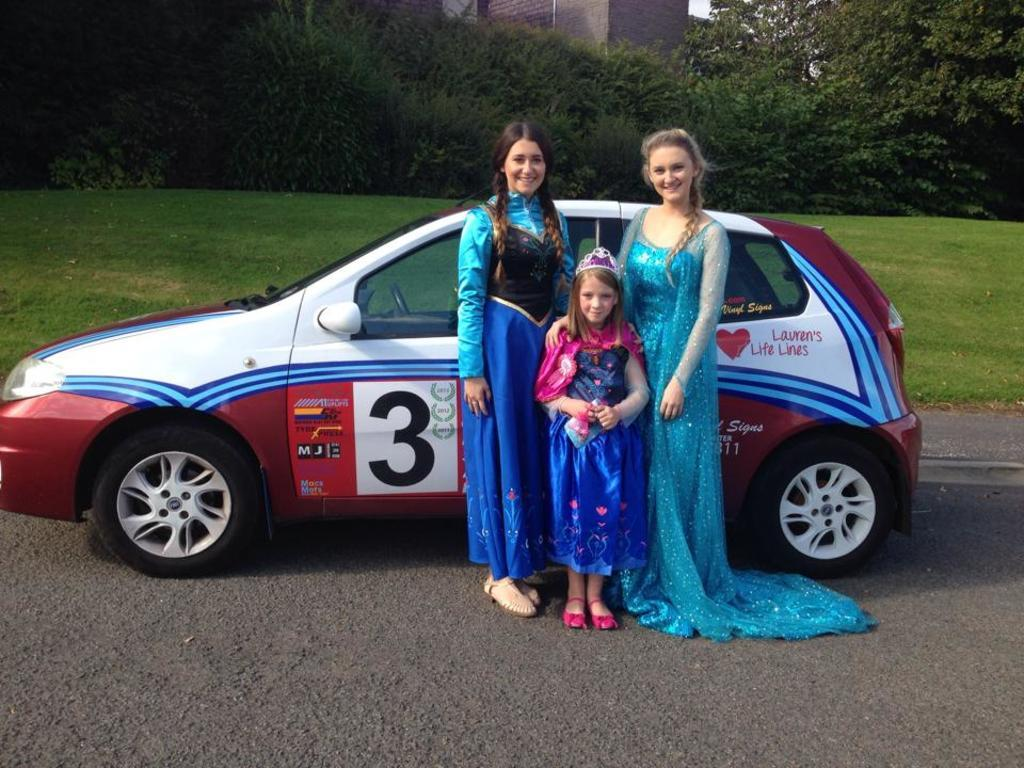How many people are visible in the image? There are three people standing in the front of the image. What type of vehicle is present in the image? There is a car in the image. What type of vegetation can be seen in the image? There is grass in the image. What other natural elements are present in the image? There are trees in the image. What type of structure can be seen in the background of the image? There is a building in the background of the image. What type of pencil is being used by the grandfather in the image? There is no grandfather or pencil present in the image. What type of bat is flying in the image? There is no bat present in the image. 